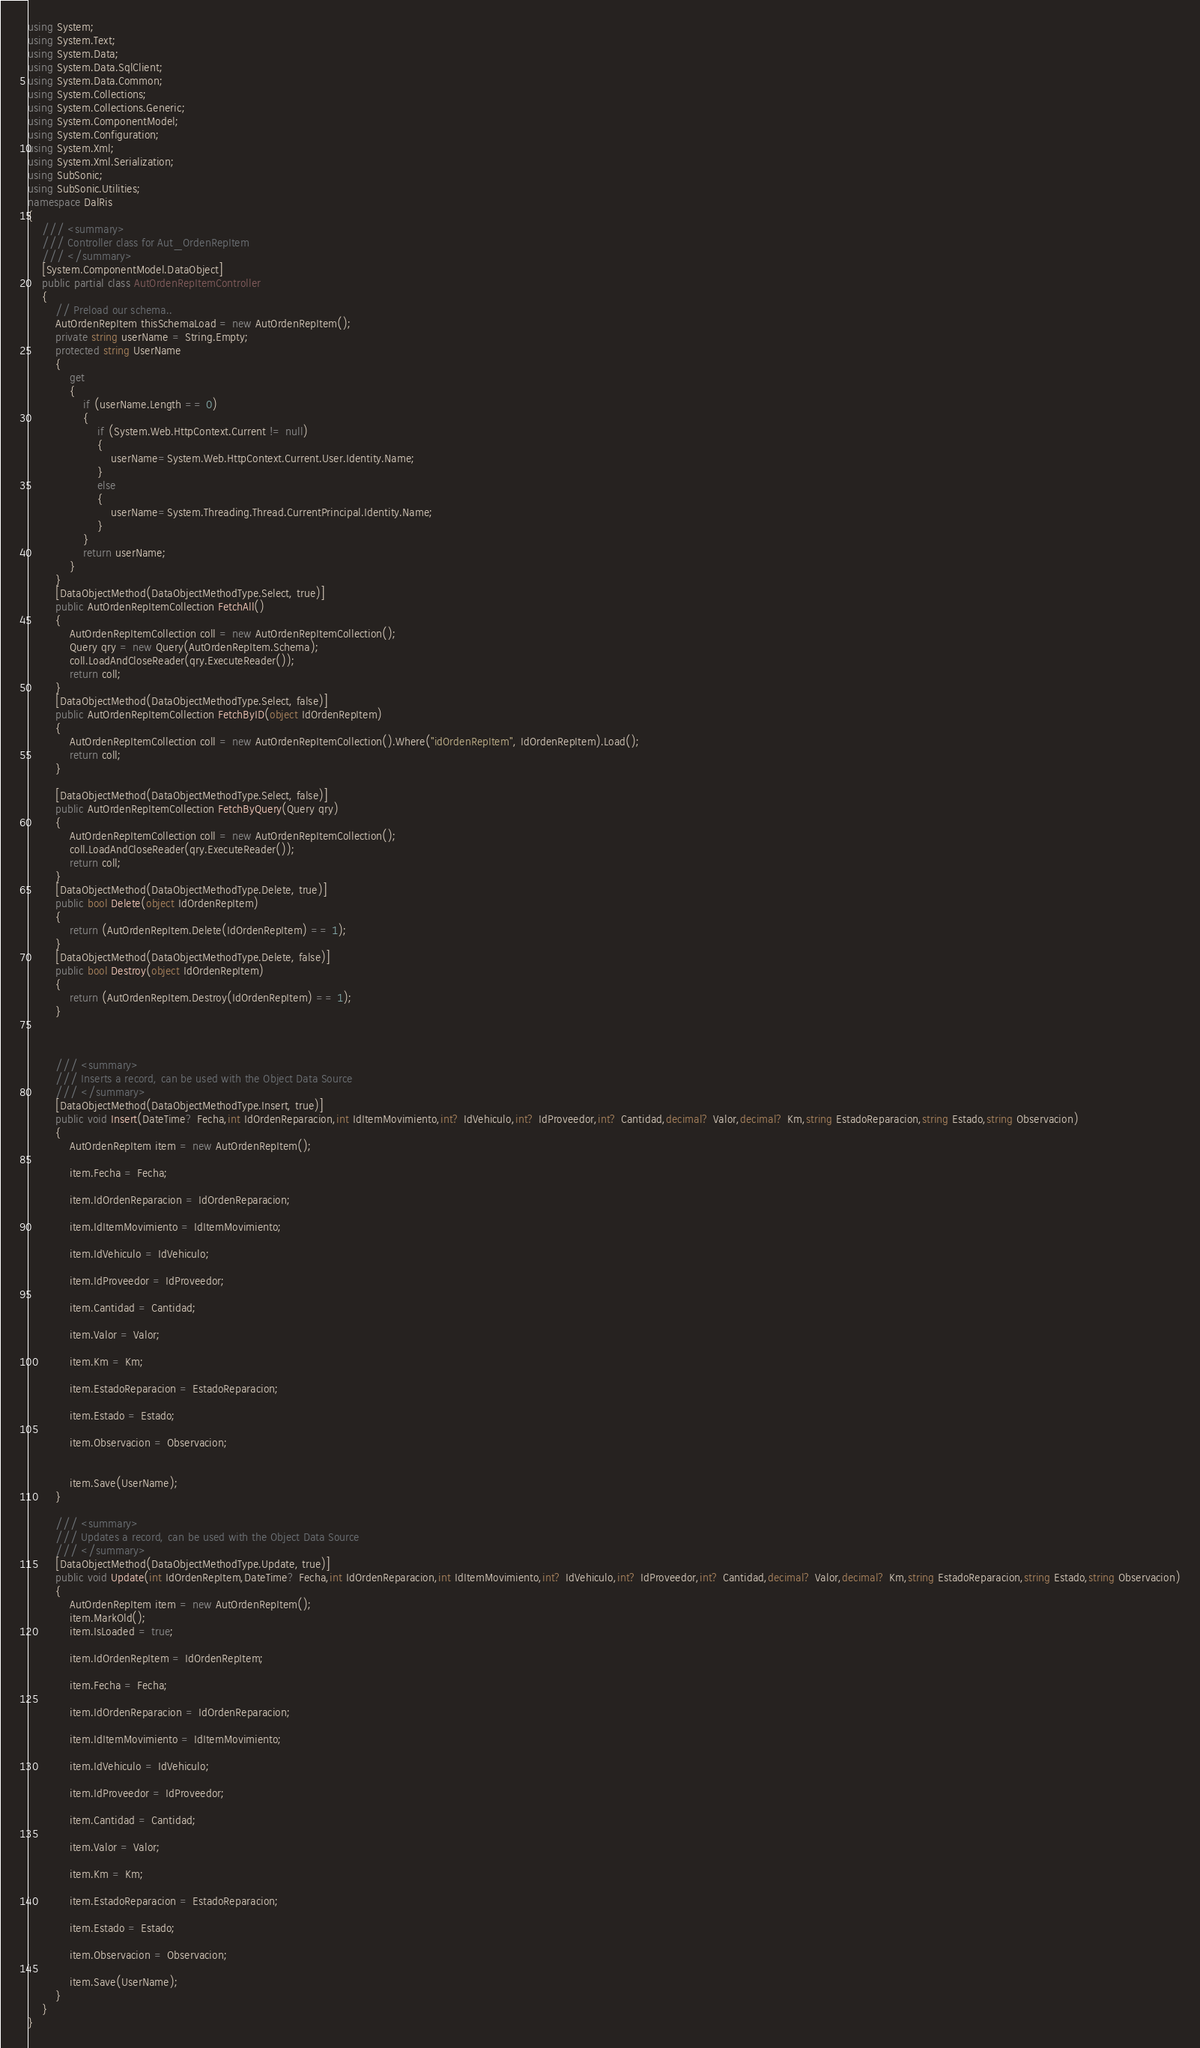Convert code to text. <code><loc_0><loc_0><loc_500><loc_500><_C#_>using System; 
using System.Text; 
using System.Data;
using System.Data.SqlClient;
using System.Data.Common;
using System.Collections;
using System.Collections.Generic;
using System.ComponentModel;
using System.Configuration; 
using System.Xml; 
using System.Xml.Serialization;
using SubSonic; 
using SubSonic.Utilities;
namespace DalRis
{
    /// <summary>
    /// Controller class for Aut_OrdenRepItem
    /// </summary>
    [System.ComponentModel.DataObject]
    public partial class AutOrdenRepItemController
    {
        // Preload our schema..
        AutOrdenRepItem thisSchemaLoad = new AutOrdenRepItem();
        private string userName = String.Empty;
        protected string UserName
        {
            get
            {
				if (userName.Length == 0) 
				{
    				if (System.Web.HttpContext.Current != null)
    				{
						userName=System.Web.HttpContext.Current.User.Identity.Name;
					}
					else
					{
						userName=System.Threading.Thread.CurrentPrincipal.Identity.Name;
					}
				}
				return userName;
            }
        }
        [DataObjectMethod(DataObjectMethodType.Select, true)]
        public AutOrdenRepItemCollection FetchAll()
        {
            AutOrdenRepItemCollection coll = new AutOrdenRepItemCollection();
            Query qry = new Query(AutOrdenRepItem.Schema);
            coll.LoadAndCloseReader(qry.ExecuteReader());
            return coll;
        }
        [DataObjectMethod(DataObjectMethodType.Select, false)]
        public AutOrdenRepItemCollection FetchByID(object IdOrdenRepItem)
        {
            AutOrdenRepItemCollection coll = new AutOrdenRepItemCollection().Where("idOrdenRepItem", IdOrdenRepItem).Load();
            return coll;
        }
		
		[DataObjectMethod(DataObjectMethodType.Select, false)]
        public AutOrdenRepItemCollection FetchByQuery(Query qry)
        {
            AutOrdenRepItemCollection coll = new AutOrdenRepItemCollection();
            coll.LoadAndCloseReader(qry.ExecuteReader()); 
            return coll;
        }
        [DataObjectMethod(DataObjectMethodType.Delete, true)]
        public bool Delete(object IdOrdenRepItem)
        {
            return (AutOrdenRepItem.Delete(IdOrdenRepItem) == 1);
        }
        [DataObjectMethod(DataObjectMethodType.Delete, false)]
        public bool Destroy(object IdOrdenRepItem)
        {
            return (AutOrdenRepItem.Destroy(IdOrdenRepItem) == 1);
        }
        
        
    	
	    /// <summary>
	    /// Inserts a record, can be used with the Object Data Source
	    /// </summary>
        [DataObjectMethod(DataObjectMethodType.Insert, true)]
	    public void Insert(DateTime? Fecha,int IdOrdenReparacion,int IdItemMovimiento,int? IdVehiculo,int? IdProveedor,int? Cantidad,decimal? Valor,decimal? Km,string EstadoReparacion,string Estado,string Observacion)
	    {
		    AutOrdenRepItem item = new AutOrdenRepItem();
		    
            item.Fecha = Fecha;
            
            item.IdOrdenReparacion = IdOrdenReparacion;
            
            item.IdItemMovimiento = IdItemMovimiento;
            
            item.IdVehiculo = IdVehiculo;
            
            item.IdProveedor = IdProveedor;
            
            item.Cantidad = Cantidad;
            
            item.Valor = Valor;
            
            item.Km = Km;
            
            item.EstadoReparacion = EstadoReparacion;
            
            item.Estado = Estado;
            
            item.Observacion = Observacion;
            
	    
		    item.Save(UserName);
	    }
    	
	    /// <summary>
	    /// Updates a record, can be used with the Object Data Source
	    /// </summary>
        [DataObjectMethod(DataObjectMethodType.Update, true)]
	    public void Update(int IdOrdenRepItem,DateTime? Fecha,int IdOrdenReparacion,int IdItemMovimiento,int? IdVehiculo,int? IdProveedor,int? Cantidad,decimal? Valor,decimal? Km,string EstadoReparacion,string Estado,string Observacion)
	    {
		    AutOrdenRepItem item = new AutOrdenRepItem();
	        item.MarkOld();
	        item.IsLoaded = true;
		    
			item.IdOrdenRepItem = IdOrdenRepItem;
				
			item.Fecha = Fecha;
				
			item.IdOrdenReparacion = IdOrdenReparacion;
				
			item.IdItemMovimiento = IdItemMovimiento;
				
			item.IdVehiculo = IdVehiculo;
				
			item.IdProveedor = IdProveedor;
				
			item.Cantidad = Cantidad;
				
			item.Valor = Valor;
				
			item.Km = Km;
				
			item.EstadoReparacion = EstadoReparacion;
				
			item.Estado = Estado;
				
			item.Observacion = Observacion;
				
	        item.Save(UserName);
	    }
    }
}
</code> 